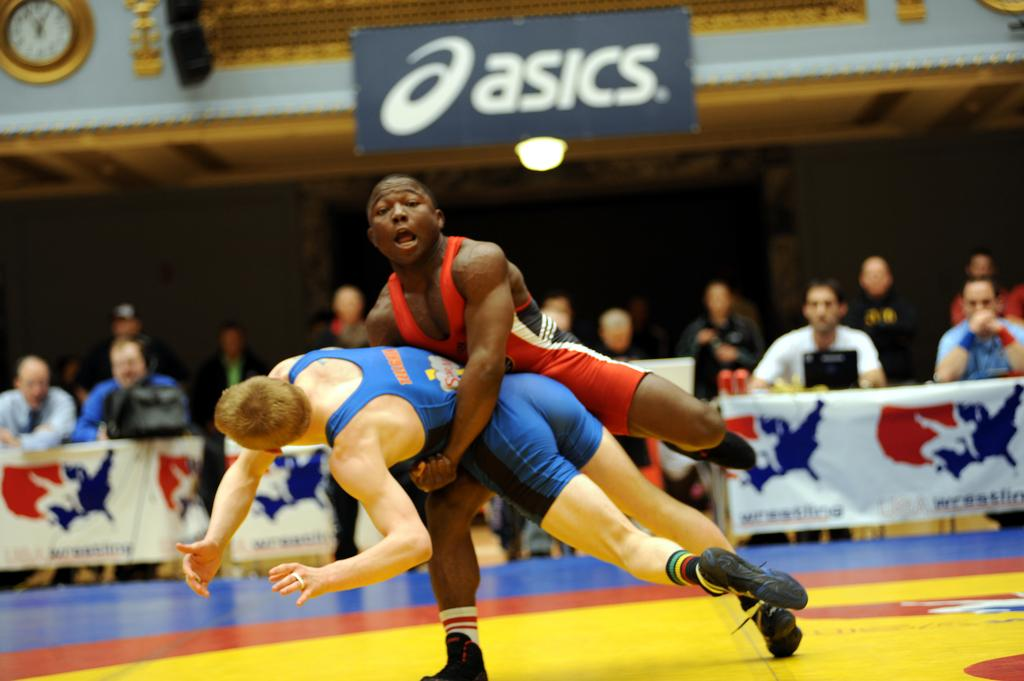<image>
Summarize the visual content of the image. people watching boys wresting with an asics sign overhead 